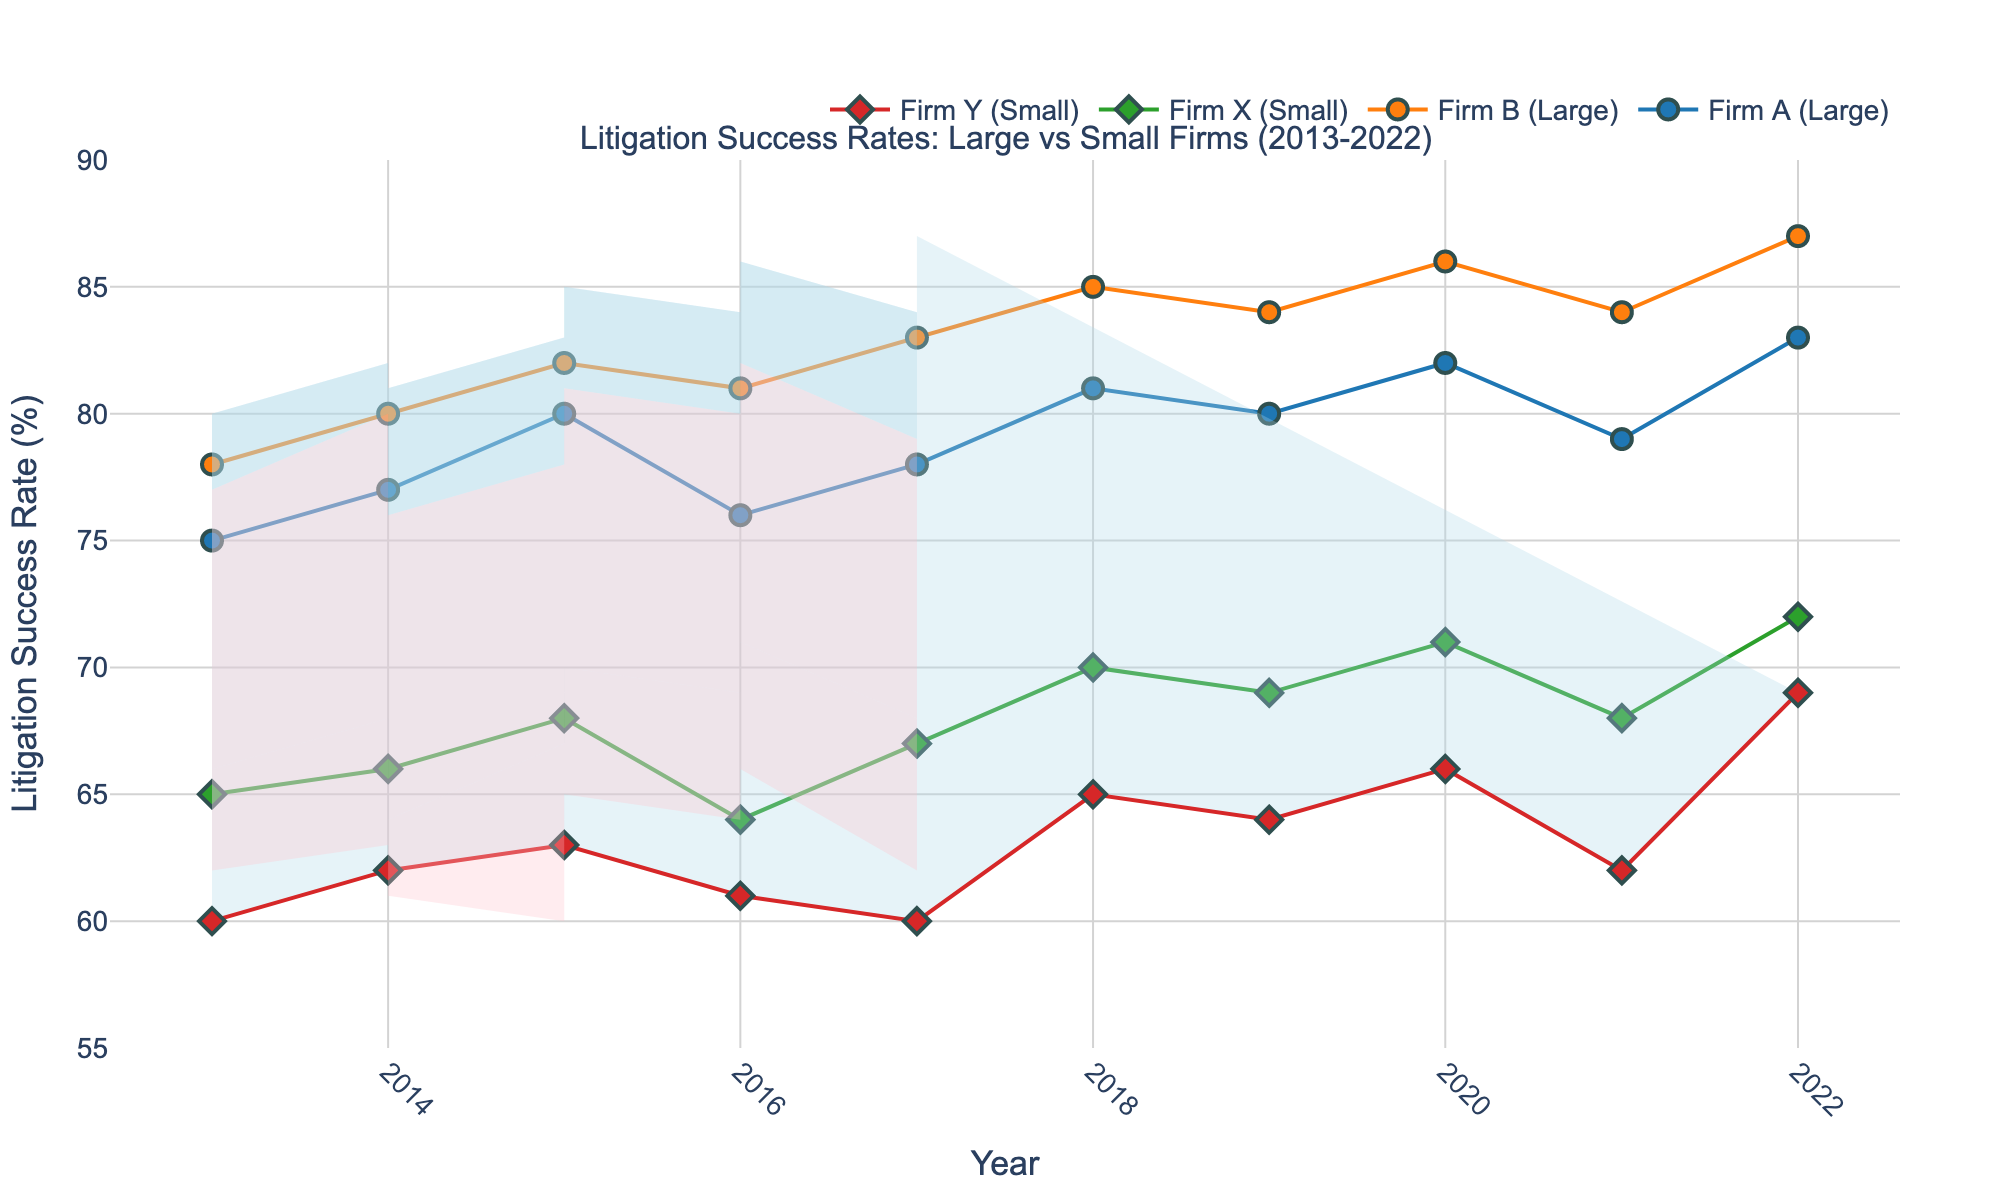What's the title of the figure? The title is usually placed at the top of the figure. Here, it reads "Litigation Success Rates: Large vs Small Firms (2013-2022)".
Answer: Litigation Success Rates: Large vs Small Firms (2013-2022) What are the years covered in this plot? The x-axis indicates the scope of the years. Here, it ranges from 2013 to 2022.
Answer: 2013-2022 Which firms are represented by circles? Circles represent large firms in the legend. Therefore, Firm A and Firm B are represented by circles.
Answer: Firm A and Firm B Which firm among large ones has the highest success rate in 2022? From the plot, look for the highest dot among circles in 2022 on the y-axis. Firm B has the highest dot at 87%.
Answer: Firm B How did the success rate of Firm X change from 2013 to 2022? Follow the line marked by diamonds (indicating small firms) for Firm X from 2013 (start at 65%) to 2022 (end at 72%).
Answer: Increased Was there an instance where Firm Y had a higher success rate than Firm X? Compare the diamonds representing Firm Y and Firm X across the years. In 2022, Firm Y's rate (69%) is higher than Firm X's (68%).
Answer: Yes What is the average success rate of Firm B over the entire period? Add the success rates of Firm B from 2013 to 2022, then divide by the number of years (10). (78+80+82+81+83+85+84+86+84+87)/10 = 83.
Answer: 83 Which firm shows the most consistent success rate within the decade? Consistent success rates imply small changes year upon year. By observing the trend line stability, Firm X has relatively small variations.
Answer: Firm X What range does the shaded area represent for large firms? The shaded area indicates the min and max success rates across years for large firms. Review the upper and lower boundaries of the blue area.
Answer: 75 to 87 